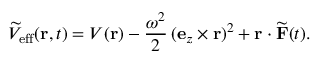<formula> <loc_0><loc_0><loc_500><loc_500>\widetilde { V } _ { e f f } ( r , t ) = V ( r ) - \frac { \omega ^ { 2 } } { 2 } \, ( e _ { z } \times r ) ^ { 2 } + r \cdot \widetilde { F } ( t ) .</formula> 